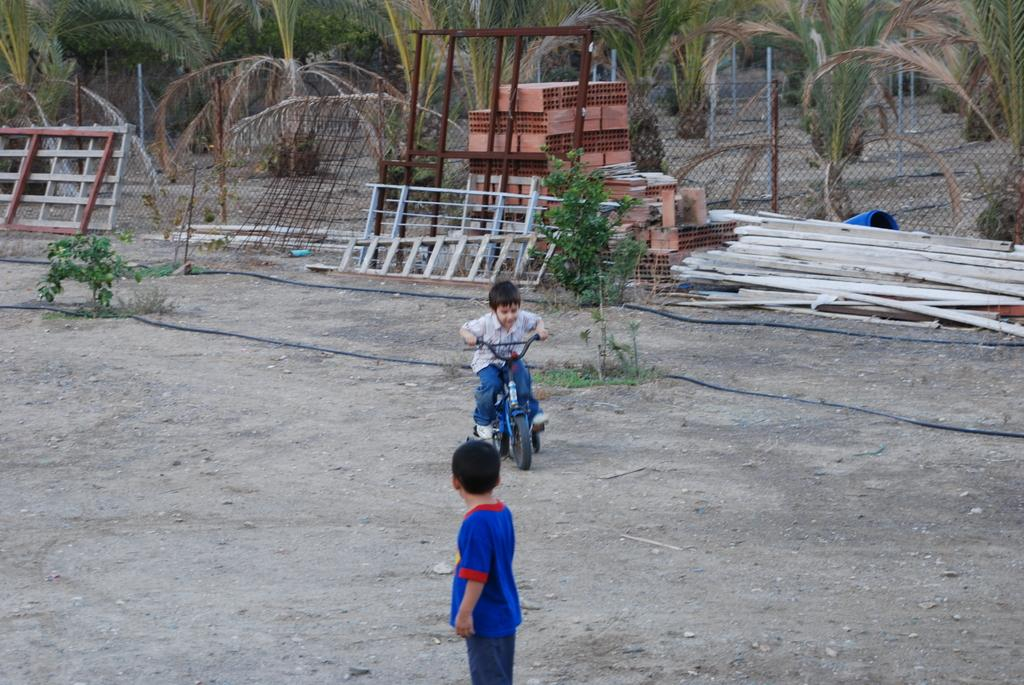How many children are in the image? There are two children in the image. What is one of the children doing in the image? One child is on a bicycle. What else can be seen in the image besides the children? There are wires visible in the image, as well as wooden objects on the ground and trees at the top of the image. What type of holiday is being celebrated in the image? There is no indication of a holiday being celebrated in the image. How much payment is being exchanged between the children in the image? There is no payment being exchanged between the children in the image. 